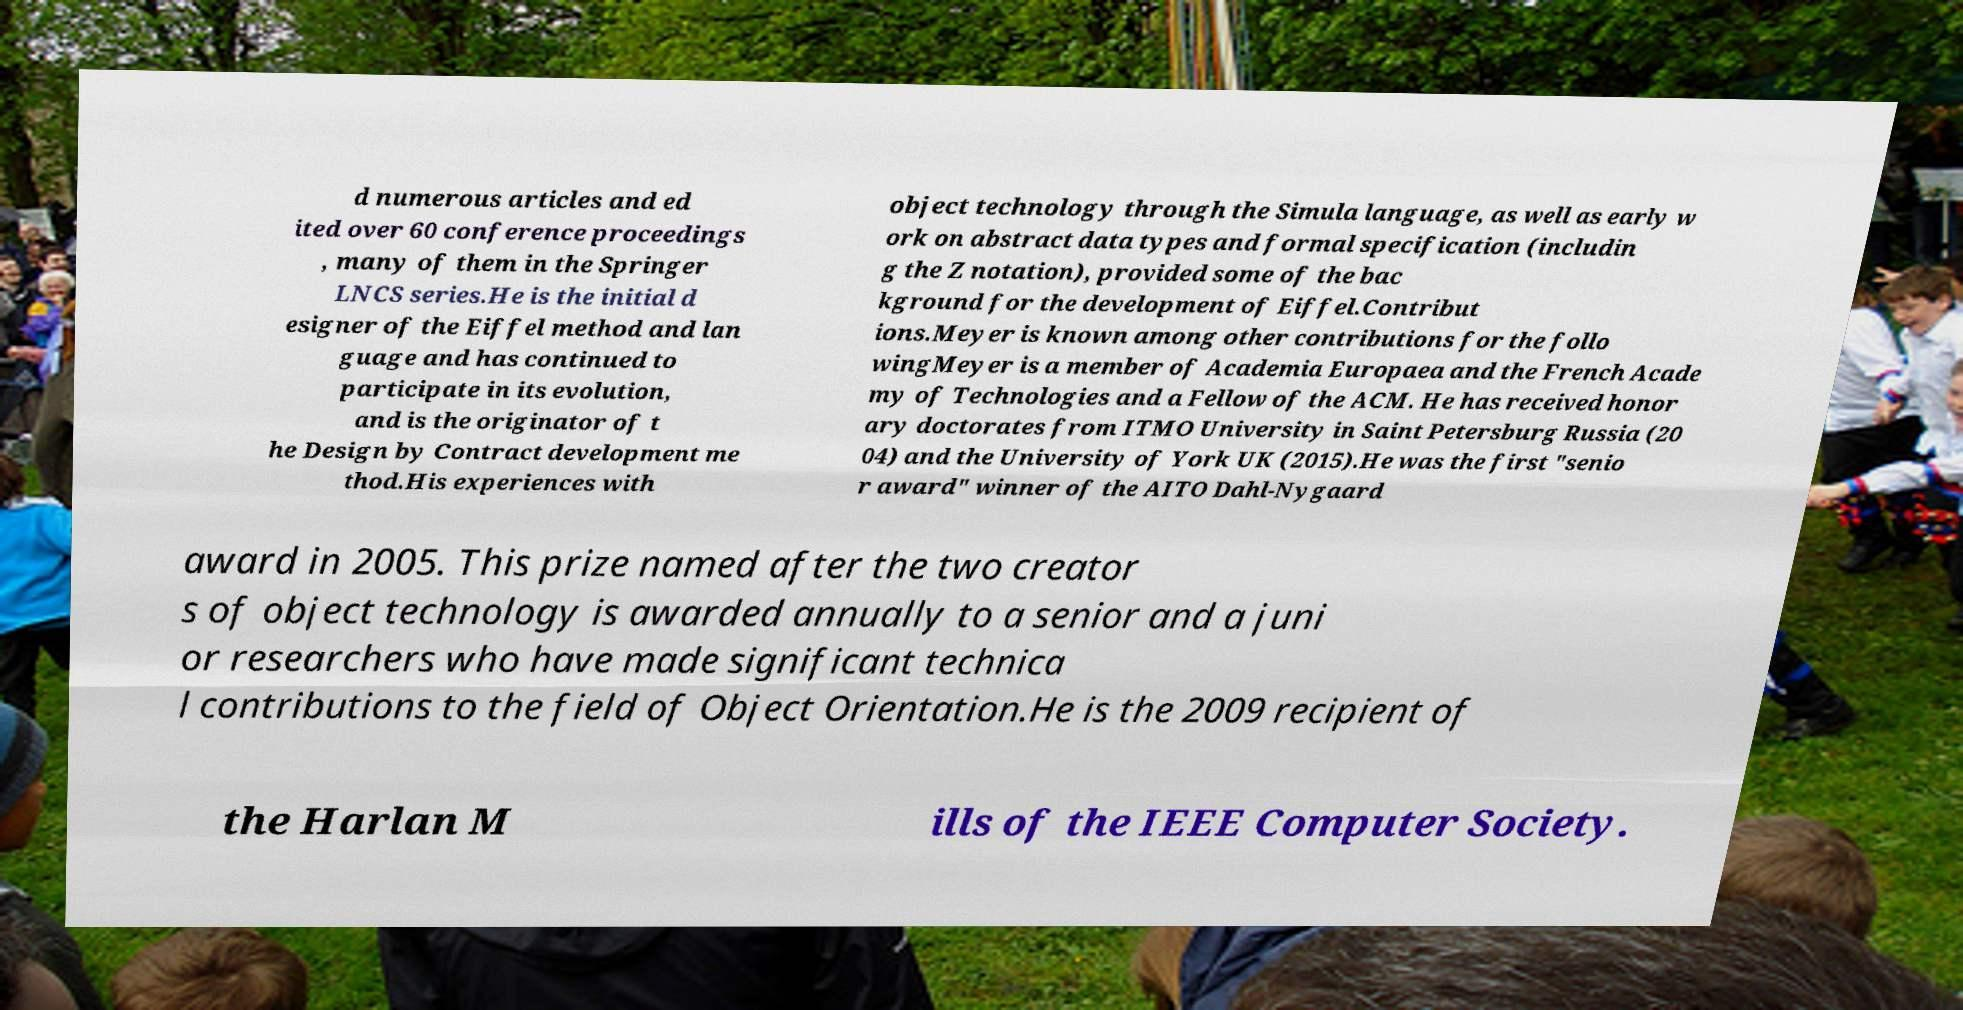There's text embedded in this image that I need extracted. Can you transcribe it verbatim? d numerous articles and ed ited over 60 conference proceedings , many of them in the Springer LNCS series.He is the initial d esigner of the Eiffel method and lan guage and has continued to participate in its evolution, and is the originator of t he Design by Contract development me thod.His experiences with object technology through the Simula language, as well as early w ork on abstract data types and formal specification (includin g the Z notation), provided some of the bac kground for the development of Eiffel.Contribut ions.Meyer is known among other contributions for the follo wingMeyer is a member of Academia Europaea and the French Acade my of Technologies and a Fellow of the ACM. He has received honor ary doctorates from ITMO University in Saint Petersburg Russia (20 04) and the University of York UK (2015).He was the first "senio r award" winner of the AITO Dahl-Nygaard award in 2005. This prize named after the two creator s of object technology is awarded annually to a senior and a juni or researchers who have made significant technica l contributions to the field of Object Orientation.He is the 2009 recipient of the Harlan M ills of the IEEE Computer Society. 